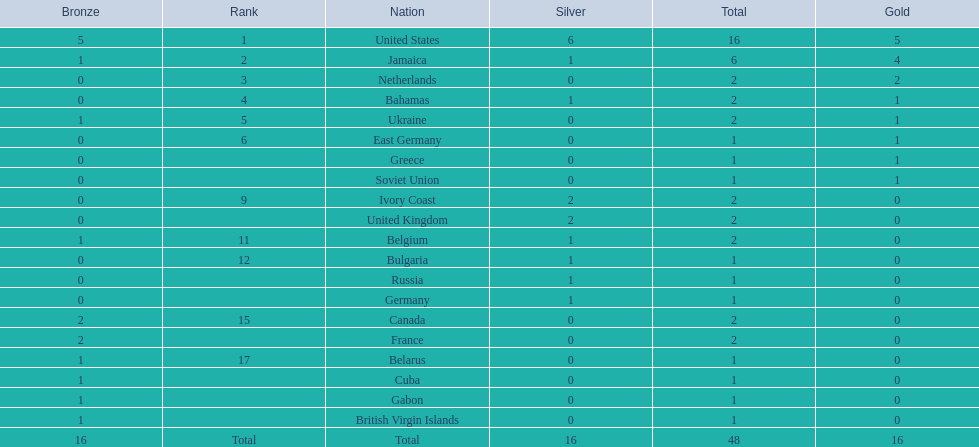How many countries secured 1 medal? 10. 